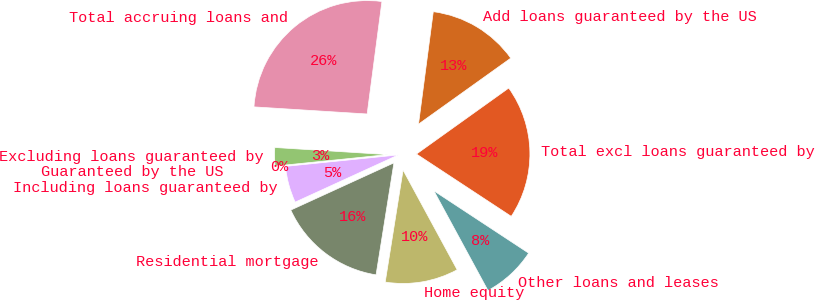Convert chart to OTSL. <chart><loc_0><loc_0><loc_500><loc_500><pie_chart><fcel>Residential mortgage<fcel>Home equity<fcel>Other loans and leases<fcel>Total excl loans guaranteed by<fcel>Add loans guaranteed by the US<fcel>Total accruing loans and<fcel>Excluding loans guaranteed by<fcel>Guaranteed by the US<fcel>Including loans guaranteed by<nl><fcel>15.65%<fcel>10.43%<fcel>7.83%<fcel>19.14%<fcel>13.04%<fcel>26.08%<fcel>2.61%<fcel>0.0%<fcel>5.22%<nl></chart> 